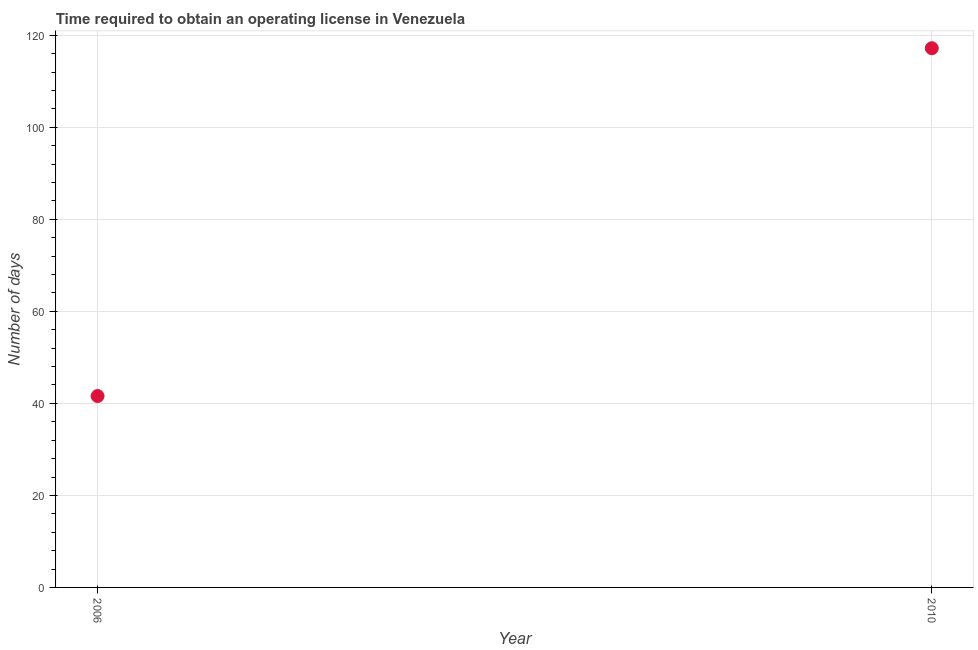What is the number of days to obtain operating license in 2006?
Provide a succinct answer. 41.6. Across all years, what is the maximum number of days to obtain operating license?
Offer a very short reply. 117.2. Across all years, what is the minimum number of days to obtain operating license?
Ensure brevity in your answer.  41.6. In which year was the number of days to obtain operating license maximum?
Ensure brevity in your answer.  2010. In which year was the number of days to obtain operating license minimum?
Ensure brevity in your answer.  2006. What is the sum of the number of days to obtain operating license?
Give a very brief answer. 158.8. What is the difference between the number of days to obtain operating license in 2006 and 2010?
Give a very brief answer. -75.6. What is the average number of days to obtain operating license per year?
Make the answer very short. 79.4. What is the median number of days to obtain operating license?
Offer a terse response. 79.4. In how many years, is the number of days to obtain operating license greater than 24 days?
Offer a terse response. 2. Do a majority of the years between 2006 and 2010 (inclusive) have number of days to obtain operating license greater than 24 days?
Keep it short and to the point. Yes. What is the ratio of the number of days to obtain operating license in 2006 to that in 2010?
Your answer should be compact. 0.35. In how many years, is the number of days to obtain operating license greater than the average number of days to obtain operating license taken over all years?
Make the answer very short. 1. Does the number of days to obtain operating license monotonically increase over the years?
Give a very brief answer. Yes. What is the difference between two consecutive major ticks on the Y-axis?
Your answer should be very brief. 20. Are the values on the major ticks of Y-axis written in scientific E-notation?
Give a very brief answer. No. Does the graph contain grids?
Make the answer very short. Yes. What is the title of the graph?
Ensure brevity in your answer.  Time required to obtain an operating license in Venezuela. What is the label or title of the Y-axis?
Give a very brief answer. Number of days. What is the Number of days in 2006?
Give a very brief answer. 41.6. What is the Number of days in 2010?
Provide a short and direct response. 117.2. What is the difference between the Number of days in 2006 and 2010?
Your response must be concise. -75.6. What is the ratio of the Number of days in 2006 to that in 2010?
Give a very brief answer. 0.35. 